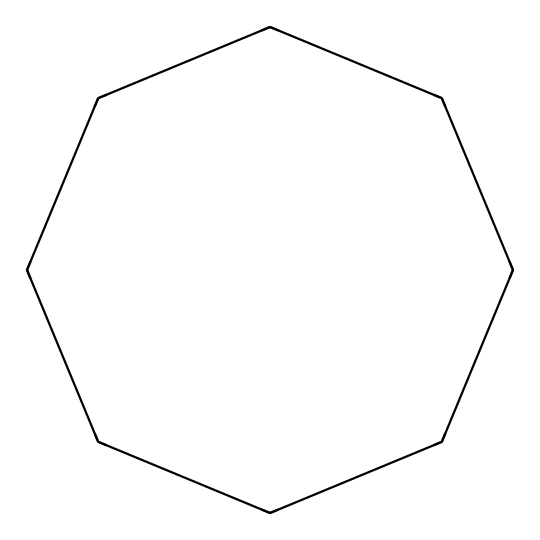What is the molecular formula of cyclooctane? The chemical structure shows a cycloalkane composed of eight carbon atoms in a ring. Each carbon atom can form two hydrogen bonds. Thus, the molecular formula is C8H16.
Answer: C8H16 How many carbon atoms are in cyclooctane? The structure indicates a ring of eight carbon atoms, which can be counted visually or from the molecular formula derived.
Answer: 8 What type of compound is cyclooctane? Cyclooctane has a ring structure with carbon atoms only and without any functional groups, classifying it as a cycloalkane.
Answer: cycloalkane What is the total number of hydrogen atoms in cyclooctane? Each of the eight carbon atoms in cyclooctane bonds to two hydrogen atoms, leading to a total count of 16 hydrogen atoms when calculated.
Answer: 16 Is cyclooctane saturated or unsaturated? The structure of cyclooctane consists solely of single bonds between the carbon atoms, indicating it is saturated with hydrogens.
Answer: saturated Can cyclooctane be used in the production of polymers? Cyclooctane serves as a precursor in the production of certain plastics and polymers due to its stable structure and ability to undergo polymerization.
Answer: Yes 